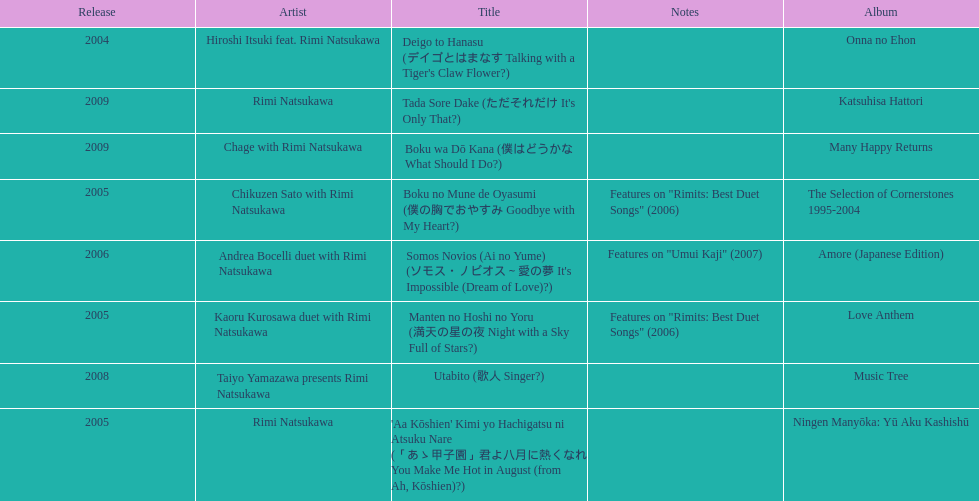Which was not released in 2004, onna no ehon or music tree? Music Tree. 